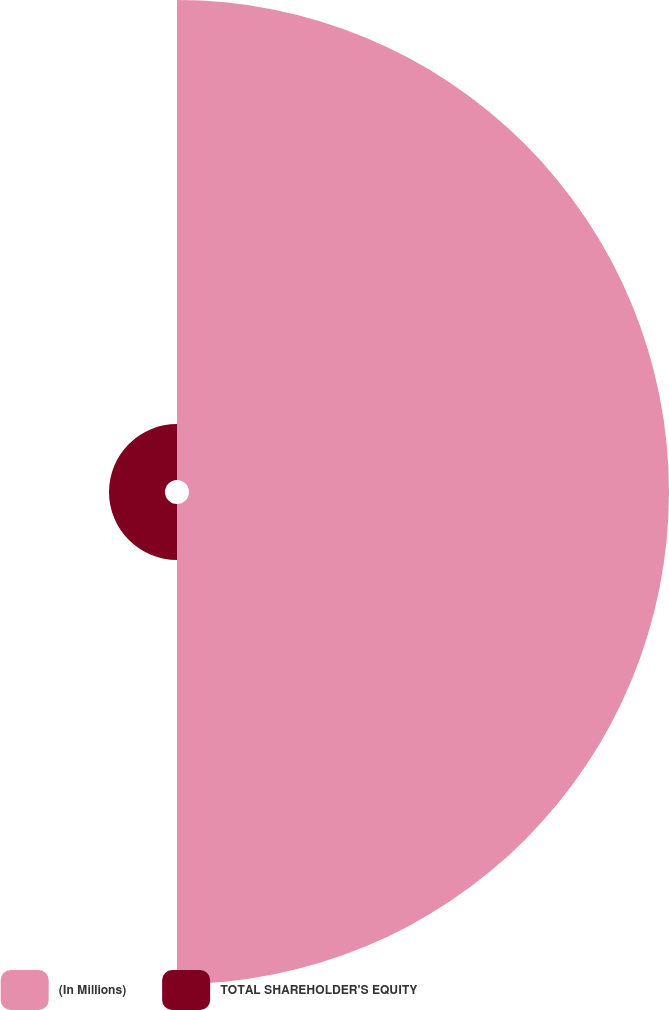<chart> <loc_0><loc_0><loc_500><loc_500><pie_chart><fcel>(In Millions)<fcel>TOTAL SHAREHOLDER'S EQUITY<nl><fcel>89.55%<fcel>10.45%<nl></chart> 